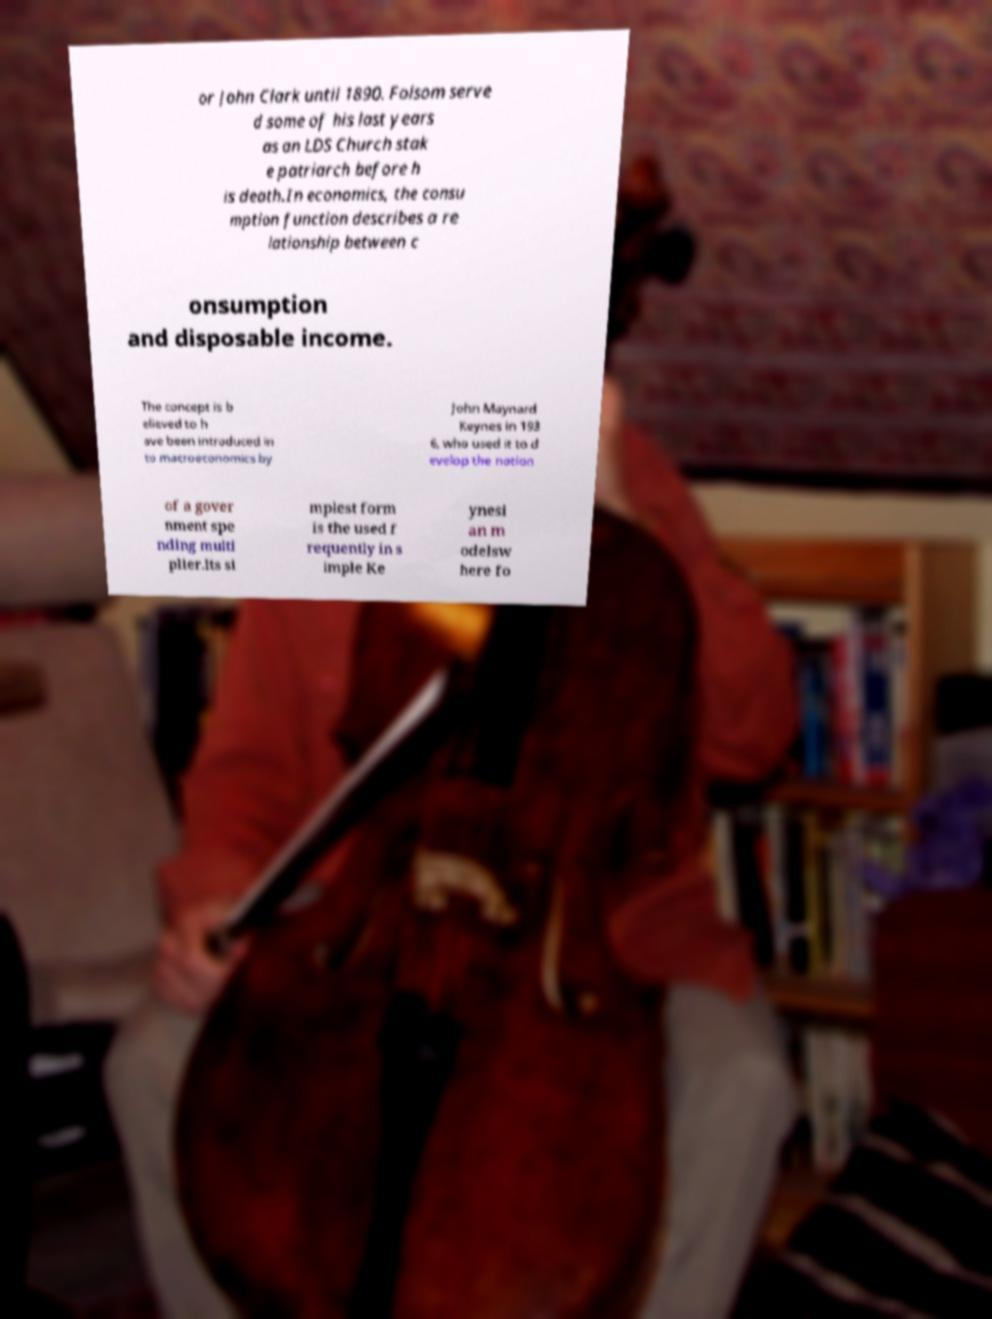Can you read and provide the text displayed in the image?This photo seems to have some interesting text. Can you extract and type it out for me? or John Clark until 1890. Folsom serve d some of his last years as an LDS Church stak e patriarch before h is death.In economics, the consu mption function describes a re lationship between c onsumption and disposable income. The concept is b elieved to h ave been introduced in to macroeconomics by John Maynard Keynes in 193 6, who used it to d evelop the notion of a gover nment spe nding multi plier.Its si mplest form is the used f requently in s imple Ke ynesi an m odelsw here fo 